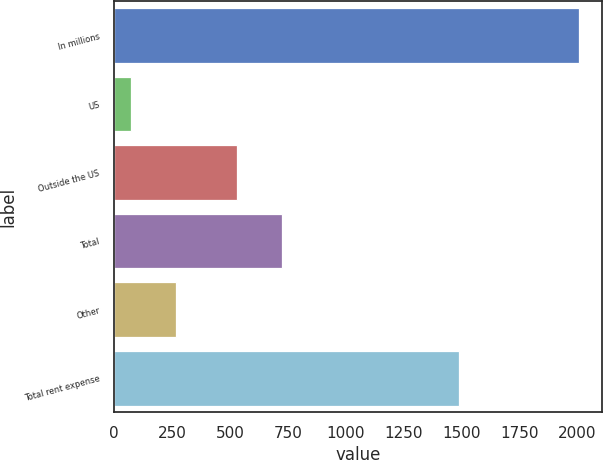Convert chart. <chart><loc_0><loc_0><loc_500><loc_500><bar_chart><fcel>In millions<fcel>US<fcel>Outside the US<fcel>Total<fcel>Other<fcel>Total rent expense<nl><fcel>2008<fcel>73.7<fcel>532<fcel>725.43<fcel>267.13<fcel>1491.6<nl></chart> 